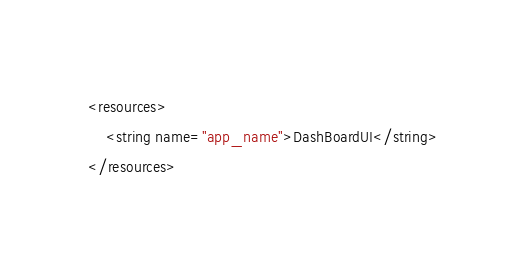Convert code to text. <code><loc_0><loc_0><loc_500><loc_500><_XML_><resources>
    <string name="app_name">DashBoardUI</string>
</resources>
</code> 